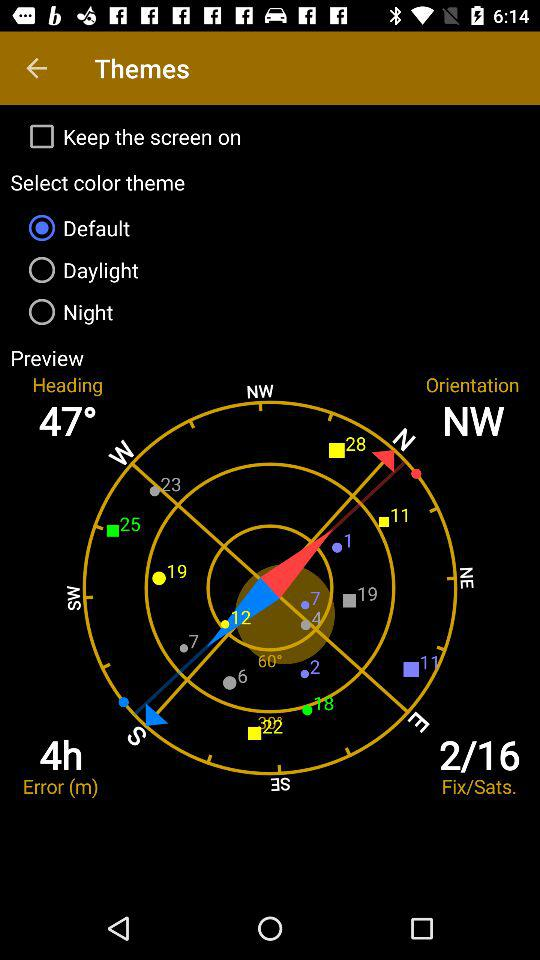Which option is selected for color theme? The selected option is "Default". 